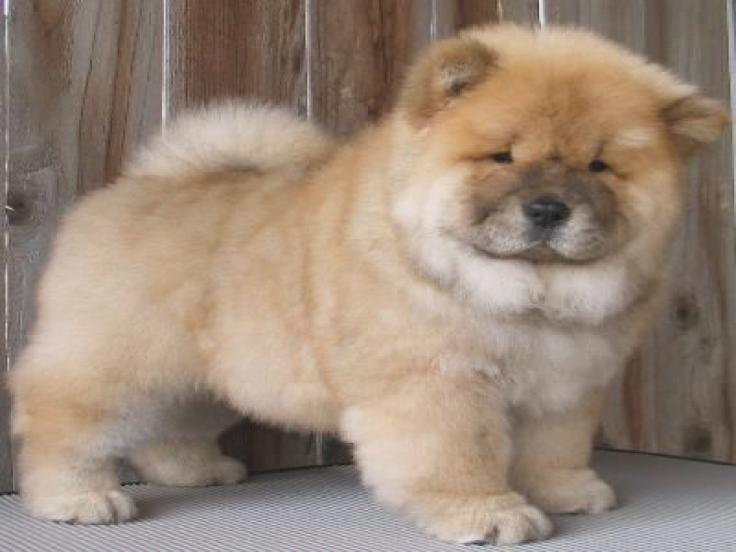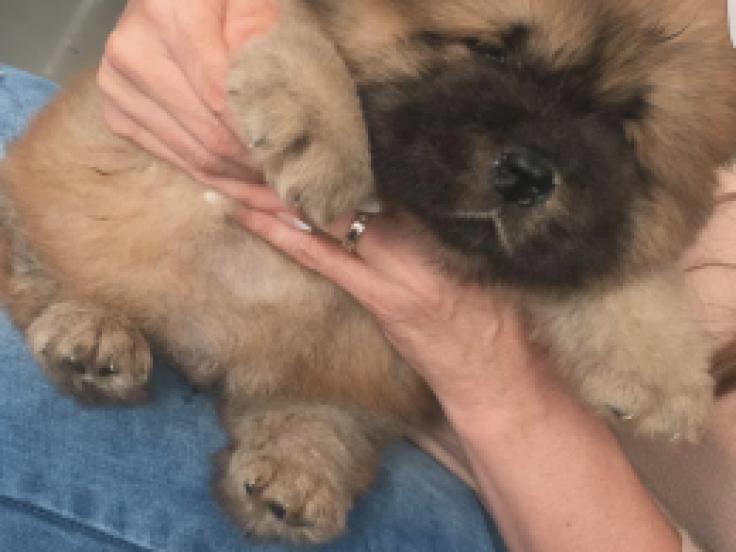The first image is the image on the left, the second image is the image on the right. Analyze the images presented: Is the assertion "There is a human handling at least one dog in the right image." valid? Answer yes or no. Yes. The first image is the image on the left, the second image is the image on the right. Given the left and right images, does the statement "A human is holding at least one Chow Chow puppy in their arms." hold true? Answer yes or no. Yes. 